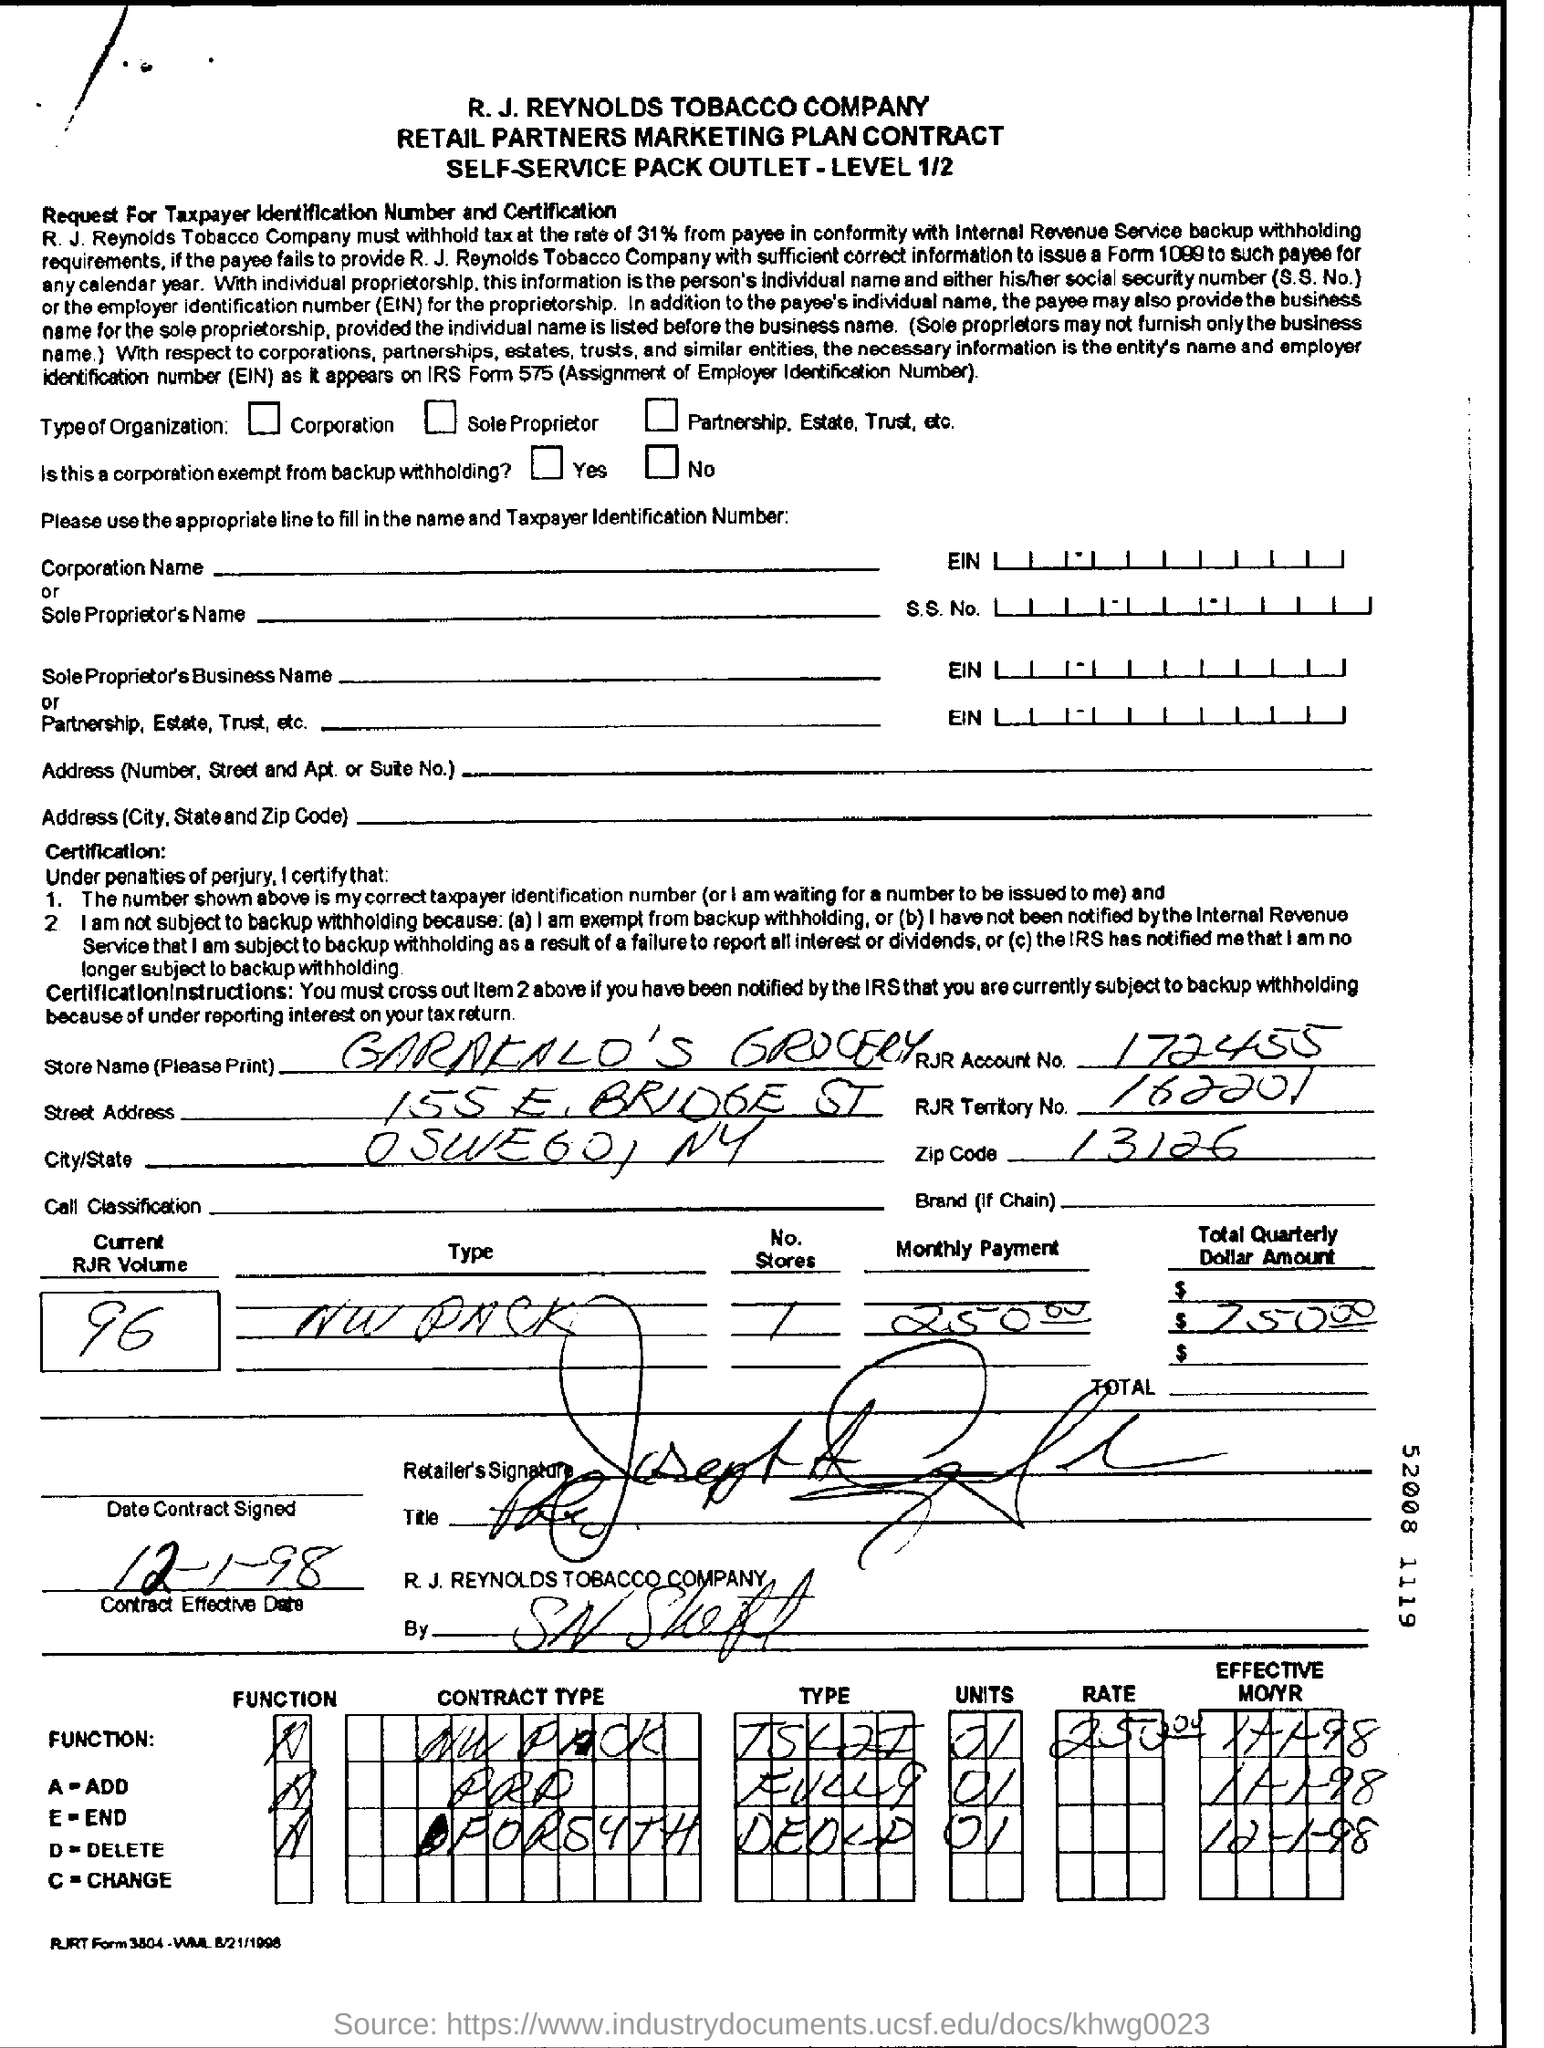What is the name of "store"?
Provide a short and direct response. Garakalo's Grocery. What is RJR Account No:?
Offer a very short reply. 172455. What is the name of the street in the address?
Provide a short and direct response. 155 E, BRIDGE ST. What is RJR territory number?
Give a very brief answer. 162201. What is zip code mentioned?
Give a very brief answer. 13126. What is current RJR volume?
Provide a succinct answer. 96. What is the monthly payment amount?
Provide a short and direct response. 250.00. 